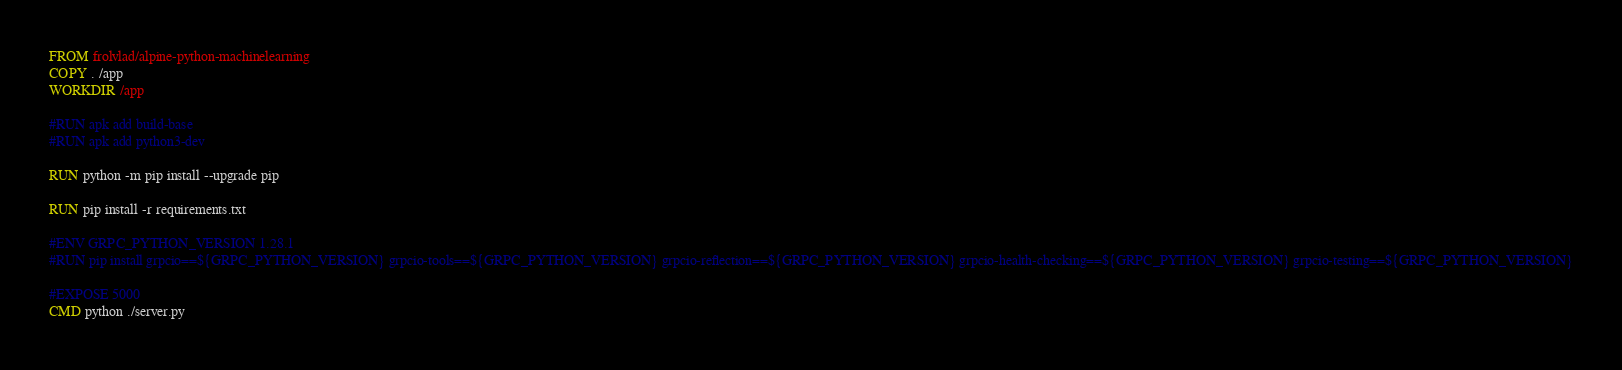<code> <loc_0><loc_0><loc_500><loc_500><_Dockerfile_>FROM frolvlad/alpine-python-machinelearning
COPY . /app
WORKDIR /app

#RUN apk add build-base
#RUN apk add python3-dev

RUN python -m pip install --upgrade pip

RUN pip install -r requirements.txt

#ENV GRPC_PYTHON_VERSION 1.28.1
#RUN pip install grpcio==${GRPC_PYTHON_VERSION} grpcio-tools==${GRPC_PYTHON_VERSION} grpcio-reflection==${GRPC_PYTHON_VERSION} grpcio-health-checking==${GRPC_PYTHON_VERSION} grpcio-testing==${GRPC_PYTHON_VERSION}

#EXPOSE 5000
CMD python ./server.py</code> 